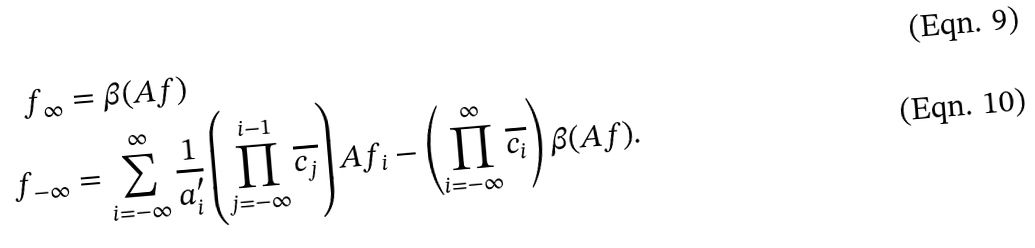Convert formula to latex. <formula><loc_0><loc_0><loc_500><loc_500>f _ { \infty } & = \beta ( A f ) \\ f _ { - \infty } & = \sum _ { i = - \infty } ^ { \infty } \frac { 1 } { a _ { i } ^ { \prime } } \left ( \prod _ { j = - \infty } ^ { i - 1 } \overline { c _ { j } } \right ) A f _ { i } - \left ( \prod _ { i = - \infty } ^ { \infty } \overline { c _ { i } } \right ) \beta ( A f ) .</formula> 